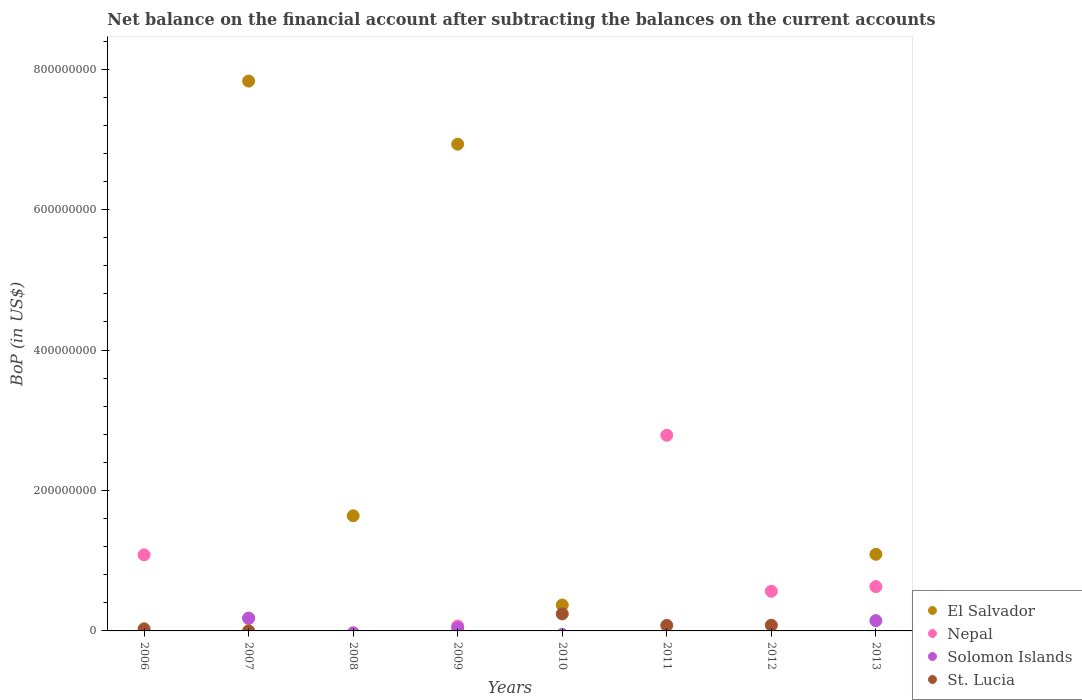Across all years, what is the maximum Balance of Payments in El Salvador?
Keep it short and to the point. 7.83e+08. Across all years, what is the minimum Balance of Payments in Solomon Islands?
Your answer should be compact. 0. In which year was the Balance of Payments in St. Lucia maximum?
Offer a very short reply. 2010. What is the total Balance of Payments in St. Lucia in the graph?
Keep it short and to the point. 4.33e+07. What is the difference between the Balance of Payments in St. Lucia in 2011 and that in 2012?
Offer a very short reply. -2.51e+05. What is the difference between the Balance of Payments in Solomon Islands in 2006 and the Balance of Payments in St. Lucia in 2011?
Offer a terse response. -7.85e+06. What is the average Balance of Payments in St. Lucia per year?
Your answer should be compact. 5.41e+06. In the year 2007, what is the difference between the Balance of Payments in Nepal and Balance of Payments in El Salvador?
Keep it short and to the point. -7.65e+08. What is the ratio of the Balance of Payments in St. Lucia in 2006 to that in 2012?
Provide a succinct answer. 0.37. Is the Balance of Payments in Nepal in 2006 less than that in 2007?
Keep it short and to the point. No. What is the difference between the highest and the second highest Balance of Payments in St. Lucia?
Provide a short and direct response. 1.62e+07. What is the difference between the highest and the lowest Balance of Payments in El Salvador?
Your answer should be very brief. 7.83e+08. Is it the case that in every year, the sum of the Balance of Payments in St. Lucia and Balance of Payments in Solomon Islands  is greater than the Balance of Payments in Nepal?
Provide a succinct answer. No. Does the Balance of Payments in St. Lucia monotonically increase over the years?
Ensure brevity in your answer.  No. Is the Balance of Payments in Solomon Islands strictly less than the Balance of Payments in St. Lucia over the years?
Give a very brief answer. No. How many dotlines are there?
Provide a short and direct response. 4. How many years are there in the graph?
Offer a very short reply. 8. Are the values on the major ticks of Y-axis written in scientific E-notation?
Offer a very short reply. No. Does the graph contain any zero values?
Provide a succinct answer. Yes. Where does the legend appear in the graph?
Give a very brief answer. Bottom right. How many legend labels are there?
Your response must be concise. 4. How are the legend labels stacked?
Give a very brief answer. Vertical. What is the title of the graph?
Provide a succinct answer. Net balance on the financial account after subtracting the balances on the current accounts. Does "Gambia, The" appear as one of the legend labels in the graph?
Ensure brevity in your answer.  No. What is the label or title of the Y-axis?
Ensure brevity in your answer.  BoP (in US$). What is the BoP (in US$) of El Salvador in 2006?
Ensure brevity in your answer.  0. What is the BoP (in US$) of Nepal in 2006?
Provide a short and direct response. 1.08e+08. What is the BoP (in US$) of St. Lucia in 2006?
Ensure brevity in your answer.  2.96e+06. What is the BoP (in US$) of El Salvador in 2007?
Make the answer very short. 7.83e+08. What is the BoP (in US$) of Nepal in 2007?
Your response must be concise. 1.77e+07. What is the BoP (in US$) in Solomon Islands in 2007?
Your response must be concise. 1.83e+07. What is the BoP (in US$) in St. Lucia in 2007?
Provide a succinct answer. 4.53e+04. What is the BoP (in US$) of El Salvador in 2008?
Provide a short and direct response. 1.64e+08. What is the BoP (in US$) of Nepal in 2008?
Keep it short and to the point. 0. What is the BoP (in US$) of St. Lucia in 2008?
Keep it short and to the point. 0. What is the BoP (in US$) in El Salvador in 2009?
Your answer should be very brief. 6.93e+08. What is the BoP (in US$) in Nepal in 2009?
Make the answer very short. 7.03e+06. What is the BoP (in US$) in Solomon Islands in 2009?
Make the answer very short. 4.36e+06. What is the BoP (in US$) of St. Lucia in 2009?
Your response must be concise. 0. What is the BoP (in US$) in El Salvador in 2010?
Provide a succinct answer. 3.69e+07. What is the BoP (in US$) of St. Lucia in 2010?
Give a very brief answer. 2.43e+07. What is the BoP (in US$) of El Salvador in 2011?
Ensure brevity in your answer.  0. What is the BoP (in US$) of Nepal in 2011?
Give a very brief answer. 2.79e+08. What is the BoP (in US$) in St. Lucia in 2011?
Ensure brevity in your answer.  7.85e+06. What is the BoP (in US$) in Nepal in 2012?
Offer a terse response. 5.65e+07. What is the BoP (in US$) in St. Lucia in 2012?
Your response must be concise. 8.10e+06. What is the BoP (in US$) of El Salvador in 2013?
Your answer should be compact. 1.09e+08. What is the BoP (in US$) of Nepal in 2013?
Provide a succinct answer. 6.31e+07. What is the BoP (in US$) of Solomon Islands in 2013?
Offer a terse response. 1.46e+07. Across all years, what is the maximum BoP (in US$) in El Salvador?
Your answer should be compact. 7.83e+08. Across all years, what is the maximum BoP (in US$) of Nepal?
Your answer should be compact. 2.79e+08. Across all years, what is the maximum BoP (in US$) in Solomon Islands?
Provide a short and direct response. 1.83e+07. Across all years, what is the maximum BoP (in US$) of St. Lucia?
Keep it short and to the point. 2.43e+07. Across all years, what is the minimum BoP (in US$) of El Salvador?
Your answer should be compact. 0. Across all years, what is the minimum BoP (in US$) of Nepal?
Your answer should be very brief. 0. Across all years, what is the minimum BoP (in US$) of Solomon Islands?
Offer a terse response. 0. Across all years, what is the minimum BoP (in US$) of St. Lucia?
Offer a terse response. 0. What is the total BoP (in US$) in El Salvador in the graph?
Offer a terse response. 1.79e+09. What is the total BoP (in US$) of Nepal in the graph?
Your response must be concise. 5.31e+08. What is the total BoP (in US$) of Solomon Islands in the graph?
Keep it short and to the point. 3.72e+07. What is the total BoP (in US$) in St. Lucia in the graph?
Provide a short and direct response. 4.33e+07. What is the difference between the BoP (in US$) in Nepal in 2006 and that in 2007?
Offer a very short reply. 9.06e+07. What is the difference between the BoP (in US$) of St. Lucia in 2006 and that in 2007?
Offer a terse response. 2.92e+06. What is the difference between the BoP (in US$) of Nepal in 2006 and that in 2009?
Offer a terse response. 1.01e+08. What is the difference between the BoP (in US$) in St. Lucia in 2006 and that in 2010?
Offer a very short reply. -2.13e+07. What is the difference between the BoP (in US$) in Nepal in 2006 and that in 2011?
Ensure brevity in your answer.  -1.70e+08. What is the difference between the BoP (in US$) of St. Lucia in 2006 and that in 2011?
Offer a very short reply. -4.89e+06. What is the difference between the BoP (in US$) of Nepal in 2006 and that in 2012?
Your response must be concise. 5.19e+07. What is the difference between the BoP (in US$) in St. Lucia in 2006 and that in 2012?
Provide a short and direct response. -5.14e+06. What is the difference between the BoP (in US$) in Nepal in 2006 and that in 2013?
Your response must be concise. 4.53e+07. What is the difference between the BoP (in US$) in El Salvador in 2007 and that in 2008?
Provide a short and direct response. 6.19e+08. What is the difference between the BoP (in US$) in El Salvador in 2007 and that in 2009?
Your answer should be very brief. 8.99e+07. What is the difference between the BoP (in US$) of Nepal in 2007 and that in 2009?
Your answer should be very brief. 1.07e+07. What is the difference between the BoP (in US$) of Solomon Islands in 2007 and that in 2009?
Provide a succinct answer. 1.39e+07. What is the difference between the BoP (in US$) of El Salvador in 2007 and that in 2010?
Provide a succinct answer. 7.46e+08. What is the difference between the BoP (in US$) in St. Lucia in 2007 and that in 2010?
Keep it short and to the point. -2.43e+07. What is the difference between the BoP (in US$) of Nepal in 2007 and that in 2011?
Provide a short and direct response. -2.61e+08. What is the difference between the BoP (in US$) in St. Lucia in 2007 and that in 2011?
Your answer should be very brief. -7.81e+06. What is the difference between the BoP (in US$) of Nepal in 2007 and that in 2012?
Give a very brief answer. -3.87e+07. What is the difference between the BoP (in US$) of St. Lucia in 2007 and that in 2012?
Keep it short and to the point. -8.06e+06. What is the difference between the BoP (in US$) in El Salvador in 2007 and that in 2013?
Make the answer very short. 6.74e+08. What is the difference between the BoP (in US$) in Nepal in 2007 and that in 2013?
Keep it short and to the point. -4.54e+07. What is the difference between the BoP (in US$) in Solomon Islands in 2007 and that in 2013?
Your response must be concise. 3.62e+06. What is the difference between the BoP (in US$) of El Salvador in 2008 and that in 2009?
Make the answer very short. -5.29e+08. What is the difference between the BoP (in US$) of El Salvador in 2008 and that in 2010?
Ensure brevity in your answer.  1.27e+08. What is the difference between the BoP (in US$) of El Salvador in 2008 and that in 2013?
Offer a very short reply. 5.49e+07. What is the difference between the BoP (in US$) in El Salvador in 2009 and that in 2010?
Provide a succinct answer. 6.56e+08. What is the difference between the BoP (in US$) in Nepal in 2009 and that in 2011?
Provide a succinct answer. -2.72e+08. What is the difference between the BoP (in US$) in Nepal in 2009 and that in 2012?
Provide a succinct answer. -4.94e+07. What is the difference between the BoP (in US$) of El Salvador in 2009 and that in 2013?
Provide a short and direct response. 5.84e+08. What is the difference between the BoP (in US$) of Nepal in 2009 and that in 2013?
Your response must be concise. -5.61e+07. What is the difference between the BoP (in US$) of Solomon Islands in 2009 and that in 2013?
Keep it short and to the point. -1.03e+07. What is the difference between the BoP (in US$) of St. Lucia in 2010 and that in 2011?
Keep it short and to the point. 1.64e+07. What is the difference between the BoP (in US$) in St. Lucia in 2010 and that in 2012?
Offer a very short reply. 1.62e+07. What is the difference between the BoP (in US$) of El Salvador in 2010 and that in 2013?
Offer a very short reply. -7.22e+07. What is the difference between the BoP (in US$) in Nepal in 2011 and that in 2012?
Your answer should be very brief. 2.22e+08. What is the difference between the BoP (in US$) of St. Lucia in 2011 and that in 2012?
Offer a terse response. -2.51e+05. What is the difference between the BoP (in US$) in Nepal in 2011 and that in 2013?
Your answer should be very brief. 2.16e+08. What is the difference between the BoP (in US$) in Nepal in 2012 and that in 2013?
Provide a succinct answer. -6.64e+06. What is the difference between the BoP (in US$) in Nepal in 2006 and the BoP (in US$) in Solomon Islands in 2007?
Provide a succinct answer. 9.01e+07. What is the difference between the BoP (in US$) in Nepal in 2006 and the BoP (in US$) in St. Lucia in 2007?
Your answer should be very brief. 1.08e+08. What is the difference between the BoP (in US$) of Nepal in 2006 and the BoP (in US$) of Solomon Islands in 2009?
Your answer should be compact. 1.04e+08. What is the difference between the BoP (in US$) in Nepal in 2006 and the BoP (in US$) in St. Lucia in 2010?
Your answer should be compact. 8.41e+07. What is the difference between the BoP (in US$) in Nepal in 2006 and the BoP (in US$) in St. Lucia in 2011?
Your answer should be very brief. 1.01e+08. What is the difference between the BoP (in US$) in Nepal in 2006 and the BoP (in US$) in St. Lucia in 2012?
Ensure brevity in your answer.  1.00e+08. What is the difference between the BoP (in US$) in Nepal in 2006 and the BoP (in US$) in Solomon Islands in 2013?
Provide a succinct answer. 9.37e+07. What is the difference between the BoP (in US$) of El Salvador in 2007 and the BoP (in US$) of Nepal in 2009?
Ensure brevity in your answer.  7.76e+08. What is the difference between the BoP (in US$) of El Salvador in 2007 and the BoP (in US$) of Solomon Islands in 2009?
Provide a short and direct response. 7.79e+08. What is the difference between the BoP (in US$) of Nepal in 2007 and the BoP (in US$) of Solomon Islands in 2009?
Offer a very short reply. 1.34e+07. What is the difference between the BoP (in US$) of El Salvador in 2007 and the BoP (in US$) of St. Lucia in 2010?
Your response must be concise. 7.59e+08. What is the difference between the BoP (in US$) of Nepal in 2007 and the BoP (in US$) of St. Lucia in 2010?
Give a very brief answer. -6.57e+06. What is the difference between the BoP (in US$) in Solomon Islands in 2007 and the BoP (in US$) in St. Lucia in 2010?
Keep it short and to the point. -6.04e+06. What is the difference between the BoP (in US$) of El Salvador in 2007 and the BoP (in US$) of Nepal in 2011?
Offer a very short reply. 5.04e+08. What is the difference between the BoP (in US$) of El Salvador in 2007 and the BoP (in US$) of St. Lucia in 2011?
Keep it short and to the point. 7.75e+08. What is the difference between the BoP (in US$) of Nepal in 2007 and the BoP (in US$) of St. Lucia in 2011?
Your answer should be very brief. 9.87e+06. What is the difference between the BoP (in US$) of Solomon Islands in 2007 and the BoP (in US$) of St. Lucia in 2011?
Your answer should be very brief. 1.04e+07. What is the difference between the BoP (in US$) of El Salvador in 2007 and the BoP (in US$) of Nepal in 2012?
Make the answer very short. 7.27e+08. What is the difference between the BoP (in US$) of El Salvador in 2007 and the BoP (in US$) of St. Lucia in 2012?
Your response must be concise. 7.75e+08. What is the difference between the BoP (in US$) of Nepal in 2007 and the BoP (in US$) of St. Lucia in 2012?
Offer a terse response. 9.62e+06. What is the difference between the BoP (in US$) of Solomon Islands in 2007 and the BoP (in US$) of St. Lucia in 2012?
Offer a very short reply. 1.02e+07. What is the difference between the BoP (in US$) in El Salvador in 2007 and the BoP (in US$) in Nepal in 2013?
Offer a very short reply. 7.20e+08. What is the difference between the BoP (in US$) of El Salvador in 2007 and the BoP (in US$) of Solomon Islands in 2013?
Make the answer very short. 7.68e+08. What is the difference between the BoP (in US$) in Nepal in 2007 and the BoP (in US$) in Solomon Islands in 2013?
Offer a very short reply. 3.09e+06. What is the difference between the BoP (in US$) of El Salvador in 2008 and the BoP (in US$) of Nepal in 2009?
Provide a succinct answer. 1.57e+08. What is the difference between the BoP (in US$) in El Salvador in 2008 and the BoP (in US$) in Solomon Islands in 2009?
Ensure brevity in your answer.  1.60e+08. What is the difference between the BoP (in US$) of El Salvador in 2008 and the BoP (in US$) of St. Lucia in 2010?
Your answer should be compact. 1.40e+08. What is the difference between the BoP (in US$) in El Salvador in 2008 and the BoP (in US$) in Nepal in 2011?
Offer a very short reply. -1.15e+08. What is the difference between the BoP (in US$) in El Salvador in 2008 and the BoP (in US$) in St. Lucia in 2011?
Provide a short and direct response. 1.56e+08. What is the difference between the BoP (in US$) in El Salvador in 2008 and the BoP (in US$) in Nepal in 2012?
Offer a very short reply. 1.08e+08. What is the difference between the BoP (in US$) of El Salvador in 2008 and the BoP (in US$) of St. Lucia in 2012?
Provide a succinct answer. 1.56e+08. What is the difference between the BoP (in US$) of El Salvador in 2008 and the BoP (in US$) of Nepal in 2013?
Provide a succinct answer. 1.01e+08. What is the difference between the BoP (in US$) in El Salvador in 2008 and the BoP (in US$) in Solomon Islands in 2013?
Your answer should be compact. 1.49e+08. What is the difference between the BoP (in US$) of El Salvador in 2009 and the BoP (in US$) of St. Lucia in 2010?
Your answer should be compact. 6.69e+08. What is the difference between the BoP (in US$) of Nepal in 2009 and the BoP (in US$) of St. Lucia in 2010?
Provide a short and direct response. -1.73e+07. What is the difference between the BoP (in US$) in Solomon Islands in 2009 and the BoP (in US$) in St. Lucia in 2010?
Offer a very short reply. -1.99e+07. What is the difference between the BoP (in US$) in El Salvador in 2009 and the BoP (in US$) in Nepal in 2011?
Make the answer very short. 4.15e+08. What is the difference between the BoP (in US$) of El Salvador in 2009 and the BoP (in US$) of St. Lucia in 2011?
Your response must be concise. 6.85e+08. What is the difference between the BoP (in US$) in Nepal in 2009 and the BoP (in US$) in St. Lucia in 2011?
Your response must be concise. -8.20e+05. What is the difference between the BoP (in US$) in Solomon Islands in 2009 and the BoP (in US$) in St. Lucia in 2011?
Keep it short and to the point. -3.49e+06. What is the difference between the BoP (in US$) in El Salvador in 2009 and the BoP (in US$) in Nepal in 2012?
Give a very brief answer. 6.37e+08. What is the difference between the BoP (in US$) of El Salvador in 2009 and the BoP (in US$) of St. Lucia in 2012?
Your answer should be very brief. 6.85e+08. What is the difference between the BoP (in US$) in Nepal in 2009 and the BoP (in US$) in St. Lucia in 2012?
Your response must be concise. -1.07e+06. What is the difference between the BoP (in US$) in Solomon Islands in 2009 and the BoP (in US$) in St. Lucia in 2012?
Offer a terse response. -3.75e+06. What is the difference between the BoP (in US$) of El Salvador in 2009 and the BoP (in US$) of Nepal in 2013?
Make the answer very short. 6.30e+08. What is the difference between the BoP (in US$) of El Salvador in 2009 and the BoP (in US$) of Solomon Islands in 2013?
Your response must be concise. 6.79e+08. What is the difference between the BoP (in US$) of Nepal in 2009 and the BoP (in US$) of Solomon Islands in 2013?
Keep it short and to the point. -7.60e+06. What is the difference between the BoP (in US$) of El Salvador in 2010 and the BoP (in US$) of Nepal in 2011?
Provide a short and direct response. -2.42e+08. What is the difference between the BoP (in US$) in El Salvador in 2010 and the BoP (in US$) in St. Lucia in 2011?
Your response must be concise. 2.91e+07. What is the difference between the BoP (in US$) of El Salvador in 2010 and the BoP (in US$) of Nepal in 2012?
Your response must be concise. -1.96e+07. What is the difference between the BoP (in US$) of El Salvador in 2010 and the BoP (in US$) of St. Lucia in 2012?
Provide a short and direct response. 2.88e+07. What is the difference between the BoP (in US$) of El Salvador in 2010 and the BoP (in US$) of Nepal in 2013?
Your answer should be compact. -2.62e+07. What is the difference between the BoP (in US$) of El Salvador in 2010 and the BoP (in US$) of Solomon Islands in 2013?
Make the answer very short. 2.23e+07. What is the difference between the BoP (in US$) of Nepal in 2011 and the BoP (in US$) of St. Lucia in 2012?
Provide a short and direct response. 2.71e+08. What is the difference between the BoP (in US$) of Nepal in 2011 and the BoP (in US$) of Solomon Islands in 2013?
Ensure brevity in your answer.  2.64e+08. What is the difference between the BoP (in US$) in Nepal in 2012 and the BoP (in US$) in Solomon Islands in 2013?
Offer a very short reply. 4.18e+07. What is the average BoP (in US$) in El Salvador per year?
Your answer should be very brief. 2.23e+08. What is the average BoP (in US$) in Nepal per year?
Provide a succinct answer. 6.64e+07. What is the average BoP (in US$) of Solomon Islands per year?
Provide a succinct answer. 4.66e+06. What is the average BoP (in US$) in St. Lucia per year?
Ensure brevity in your answer.  5.41e+06. In the year 2006, what is the difference between the BoP (in US$) in Nepal and BoP (in US$) in St. Lucia?
Provide a succinct answer. 1.05e+08. In the year 2007, what is the difference between the BoP (in US$) of El Salvador and BoP (in US$) of Nepal?
Your response must be concise. 7.65e+08. In the year 2007, what is the difference between the BoP (in US$) in El Salvador and BoP (in US$) in Solomon Islands?
Keep it short and to the point. 7.65e+08. In the year 2007, what is the difference between the BoP (in US$) in El Salvador and BoP (in US$) in St. Lucia?
Keep it short and to the point. 7.83e+08. In the year 2007, what is the difference between the BoP (in US$) of Nepal and BoP (in US$) of Solomon Islands?
Give a very brief answer. -5.30e+05. In the year 2007, what is the difference between the BoP (in US$) in Nepal and BoP (in US$) in St. Lucia?
Provide a short and direct response. 1.77e+07. In the year 2007, what is the difference between the BoP (in US$) of Solomon Islands and BoP (in US$) of St. Lucia?
Your answer should be very brief. 1.82e+07. In the year 2009, what is the difference between the BoP (in US$) of El Salvador and BoP (in US$) of Nepal?
Your response must be concise. 6.86e+08. In the year 2009, what is the difference between the BoP (in US$) in El Salvador and BoP (in US$) in Solomon Islands?
Your answer should be very brief. 6.89e+08. In the year 2009, what is the difference between the BoP (in US$) of Nepal and BoP (in US$) of Solomon Islands?
Provide a short and direct response. 2.67e+06. In the year 2010, what is the difference between the BoP (in US$) in El Salvador and BoP (in US$) in St. Lucia?
Your answer should be compact. 1.26e+07. In the year 2011, what is the difference between the BoP (in US$) in Nepal and BoP (in US$) in St. Lucia?
Offer a very short reply. 2.71e+08. In the year 2012, what is the difference between the BoP (in US$) of Nepal and BoP (in US$) of St. Lucia?
Ensure brevity in your answer.  4.84e+07. In the year 2013, what is the difference between the BoP (in US$) of El Salvador and BoP (in US$) of Nepal?
Give a very brief answer. 4.60e+07. In the year 2013, what is the difference between the BoP (in US$) in El Salvador and BoP (in US$) in Solomon Islands?
Your answer should be compact. 9.45e+07. In the year 2013, what is the difference between the BoP (in US$) of Nepal and BoP (in US$) of Solomon Islands?
Provide a succinct answer. 4.85e+07. What is the ratio of the BoP (in US$) of Nepal in 2006 to that in 2007?
Provide a short and direct response. 6.11. What is the ratio of the BoP (in US$) in St. Lucia in 2006 to that in 2007?
Provide a short and direct response. 65.34. What is the ratio of the BoP (in US$) in Nepal in 2006 to that in 2009?
Keep it short and to the point. 15.41. What is the ratio of the BoP (in US$) in St. Lucia in 2006 to that in 2010?
Offer a very short reply. 0.12. What is the ratio of the BoP (in US$) of Nepal in 2006 to that in 2011?
Keep it short and to the point. 0.39. What is the ratio of the BoP (in US$) of St. Lucia in 2006 to that in 2011?
Your answer should be compact. 0.38. What is the ratio of the BoP (in US$) of Nepal in 2006 to that in 2012?
Make the answer very short. 1.92. What is the ratio of the BoP (in US$) of St. Lucia in 2006 to that in 2012?
Provide a short and direct response. 0.37. What is the ratio of the BoP (in US$) in Nepal in 2006 to that in 2013?
Your answer should be compact. 1.72. What is the ratio of the BoP (in US$) in El Salvador in 2007 to that in 2008?
Your answer should be compact. 4.78. What is the ratio of the BoP (in US$) in El Salvador in 2007 to that in 2009?
Make the answer very short. 1.13. What is the ratio of the BoP (in US$) of Nepal in 2007 to that in 2009?
Keep it short and to the point. 2.52. What is the ratio of the BoP (in US$) in Solomon Islands in 2007 to that in 2009?
Make the answer very short. 4.19. What is the ratio of the BoP (in US$) of El Salvador in 2007 to that in 2010?
Your response must be concise. 21.22. What is the ratio of the BoP (in US$) of St. Lucia in 2007 to that in 2010?
Your answer should be compact. 0. What is the ratio of the BoP (in US$) in Nepal in 2007 to that in 2011?
Offer a terse response. 0.06. What is the ratio of the BoP (in US$) in St. Lucia in 2007 to that in 2011?
Your answer should be very brief. 0.01. What is the ratio of the BoP (in US$) in Nepal in 2007 to that in 2012?
Your answer should be very brief. 0.31. What is the ratio of the BoP (in US$) in St. Lucia in 2007 to that in 2012?
Offer a terse response. 0.01. What is the ratio of the BoP (in US$) in El Salvador in 2007 to that in 2013?
Ensure brevity in your answer.  7.18. What is the ratio of the BoP (in US$) in Nepal in 2007 to that in 2013?
Your response must be concise. 0.28. What is the ratio of the BoP (in US$) of Solomon Islands in 2007 to that in 2013?
Give a very brief answer. 1.25. What is the ratio of the BoP (in US$) of El Salvador in 2008 to that in 2009?
Give a very brief answer. 0.24. What is the ratio of the BoP (in US$) of El Salvador in 2008 to that in 2010?
Keep it short and to the point. 4.44. What is the ratio of the BoP (in US$) of El Salvador in 2008 to that in 2013?
Your answer should be very brief. 1.5. What is the ratio of the BoP (in US$) of El Salvador in 2009 to that in 2010?
Keep it short and to the point. 18.78. What is the ratio of the BoP (in US$) of Nepal in 2009 to that in 2011?
Give a very brief answer. 0.03. What is the ratio of the BoP (in US$) in Nepal in 2009 to that in 2012?
Your response must be concise. 0.12. What is the ratio of the BoP (in US$) of El Salvador in 2009 to that in 2013?
Give a very brief answer. 6.35. What is the ratio of the BoP (in US$) of Nepal in 2009 to that in 2013?
Provide a short and direct response. 0.11. What is the ratio of the BoP (in US$) of Solomon Islands in 2009 to that in 2013?
Your answer should be very brief. 0.3. What is the ratio of the BoP (in US$) in St. Lucia in 2010 to that in 2011?
Your response must be concise. 3.09. What is the ratio of the BoP (in US$) in St. Lucia in 2010 to that in 2012?
Provide a succinct answer. 3. What is the ratio of the BoP (in US$) of El Salvador in 2010 to that in 2013?
Provide a succinct answer. 0.34. What is the ratio of the BoP (in US$) of Nepal in 2011 to that in 2012?
Offer a terse response. 4.94. What is the ratio of the BoP (in US$) in Nepal in 2011 to that in 2013?
Your answer should be very brief. 4.42. What is the ratio of the BoP (in US$) in Nepal in 2012 to that in 2013?
Your answer should be very brief. 0.89. What is the difference between the highest and the second highest BoP (in US$) of El Salvador?
Provide a succinct answer. 8.99e+07. What is the difference between the highest and the second highest BoP (in US$) of Nepal?
Ensure brevity in your answer.  1.70e+08. What is the difference between the highest and the second highest BoP (in US$) of Solomon Islands?
Give a very brief answer. 3.62e+06. What is the difference between the highest and the second highest BoP (in US$) of St. Lucia?
Offer a very short reply. 1.62e+07. What is the difference between the highest and the lowest BoP (in US$) in El Salvador?
Make the answer very short. 7.83e+08. What is the difference between the highest and the lowest BoP (in US$) of Nepal?
Keep it short and to the point. 2.79e+08. What is the difference between the highest and the lowest BoP (in US$) of Solomon Islands?
Give a very brief answer. 1.83e+07. What is the difference between the highest and the lowest BoP (in US$) in St. Lucia?
Your response must be concise. 2.43e+07. 